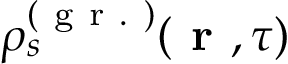<formula> <loc_0><loc_0><loc_500><loc_500>\rho _ { s } ^ { ( g r . ) } ( r , \tau )</formula> 